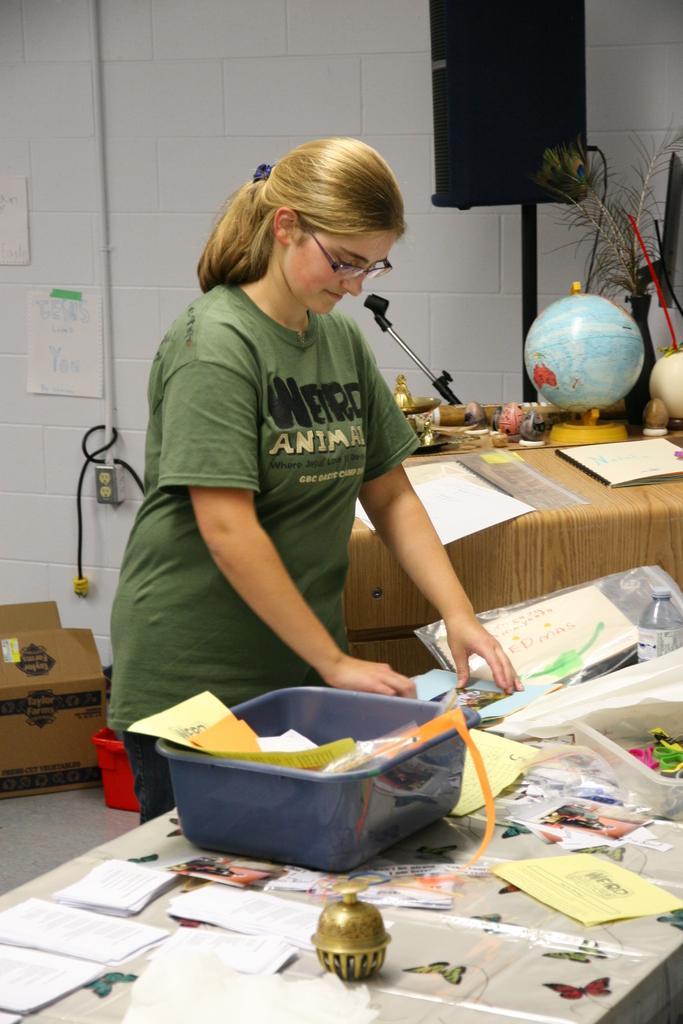In one or two sentences, can you explain what this image depicts? In this picture there is a woman who is standing near to the table. On the table I can see the basket, papers, plastic covers, water bottle, bands, box, stickers of the butterflies and other objects. On the left I can see the globe, selfie stick, papers and other objects which are places on the table. Besides that I can see the speaker which is placed near to the wall. On the left I can see the cable, socket and papers were attached on the wall. In the bottom left there is a cotton box which is kept on the floor. 